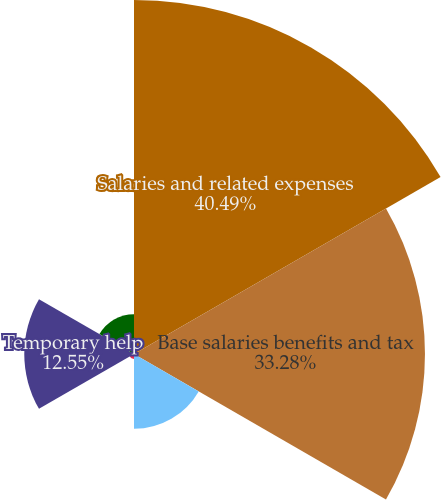<chart> <loc_0><loc_0><loc_500><loc_500><pie_chart><fcel>Salaries and related expenses<fcel>Base salaries benefits and tax<fcel>Incentive expense<fcel>Severance expense<fcel>Temporary help<fcel>All other salaries and related<nl><fcel>40.49%<fcel>33.28%<fcel>8.55%<fcel>0.57%<fcel>12.55%<fcel>4.56%<nl></chart> 